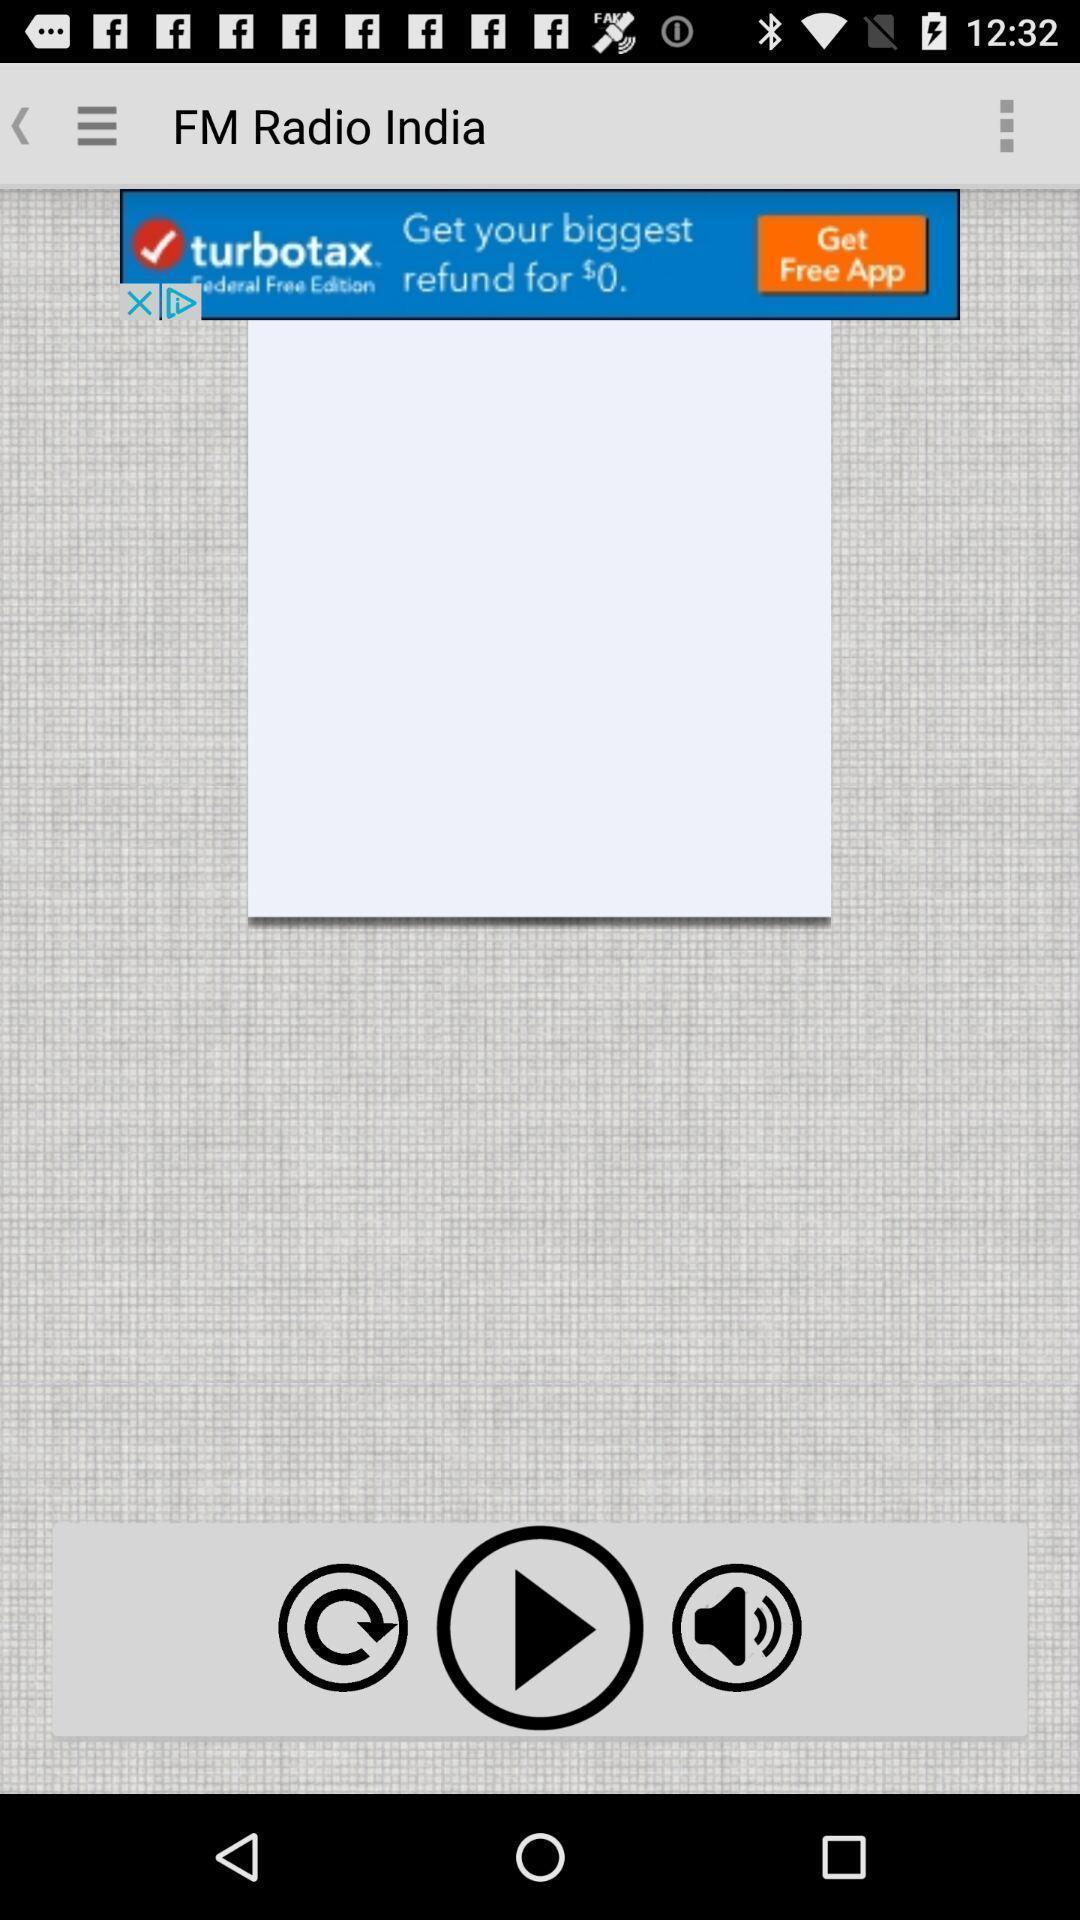Give me a summary of this screen capture. Screen showing the multiple icons. 